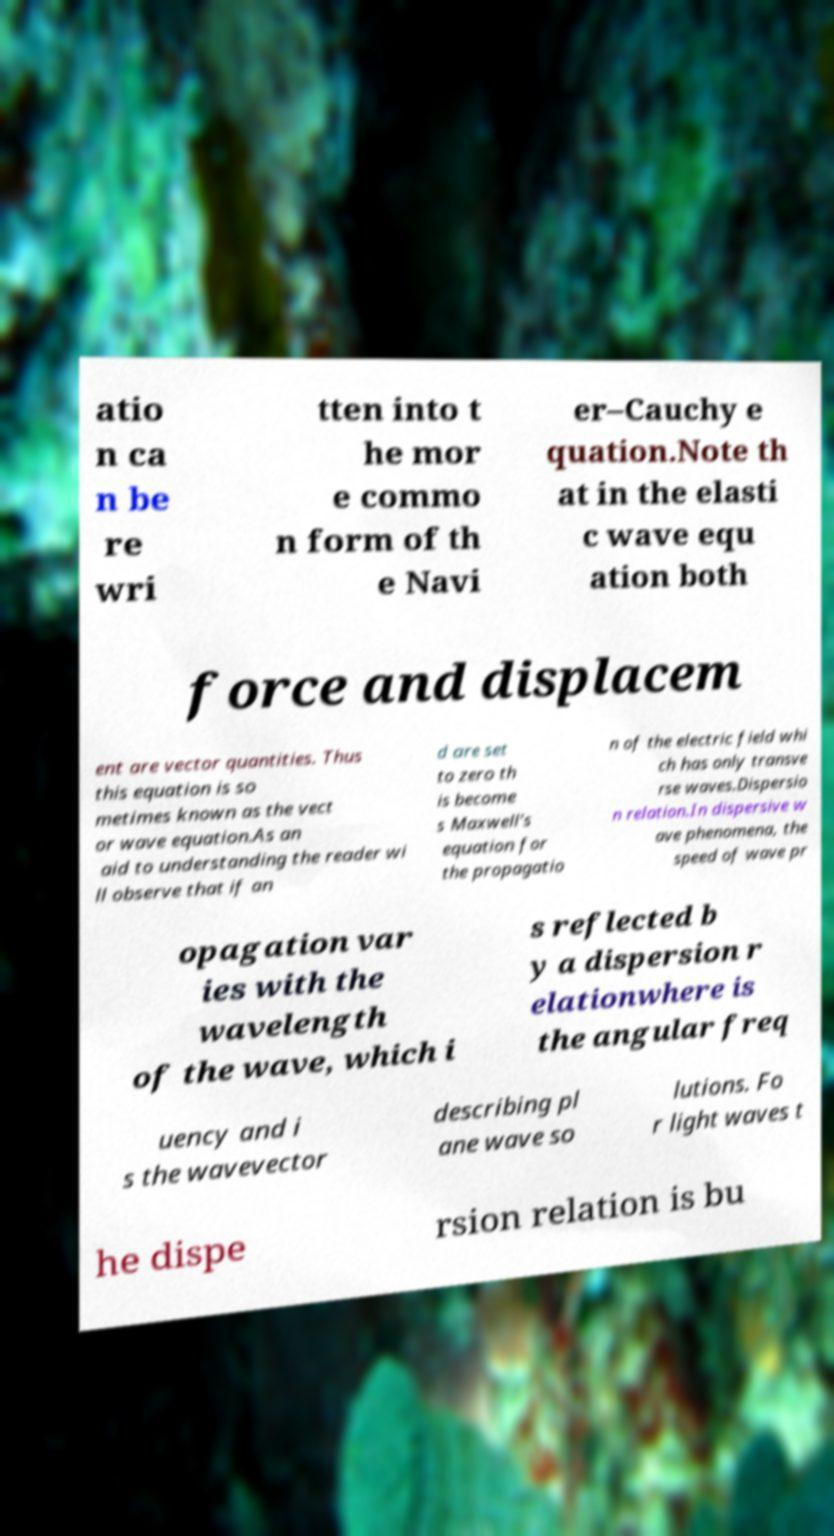Could you assist in decoding the text presented in this image and type it out clearly? atio n ca n be re wri tten into t he mor e commo n form of th e Navi er–Cauchy e quation.Note th at in the elasti c wave equ ation both force and displacem ent are vector quantities. Thus this equation is so metimes known as the vect or wave equation.As an aid to understanding the reader wi ll observe that if an d are set to zero th is become s Maxwell's equation for the propagatio n of the electric field whi ch has only transve rse waves.Dispersio n relation.In dispersive w ave phenomena, the speed of wave pr opagation var ies with the wavelength of the wave, which i s reflected b y a dispersion r elationwhere is the angular freq uency and i s the wavevector describing pl ane wave so lutions. Fo r light waves t he dispe rsion relation is bu 